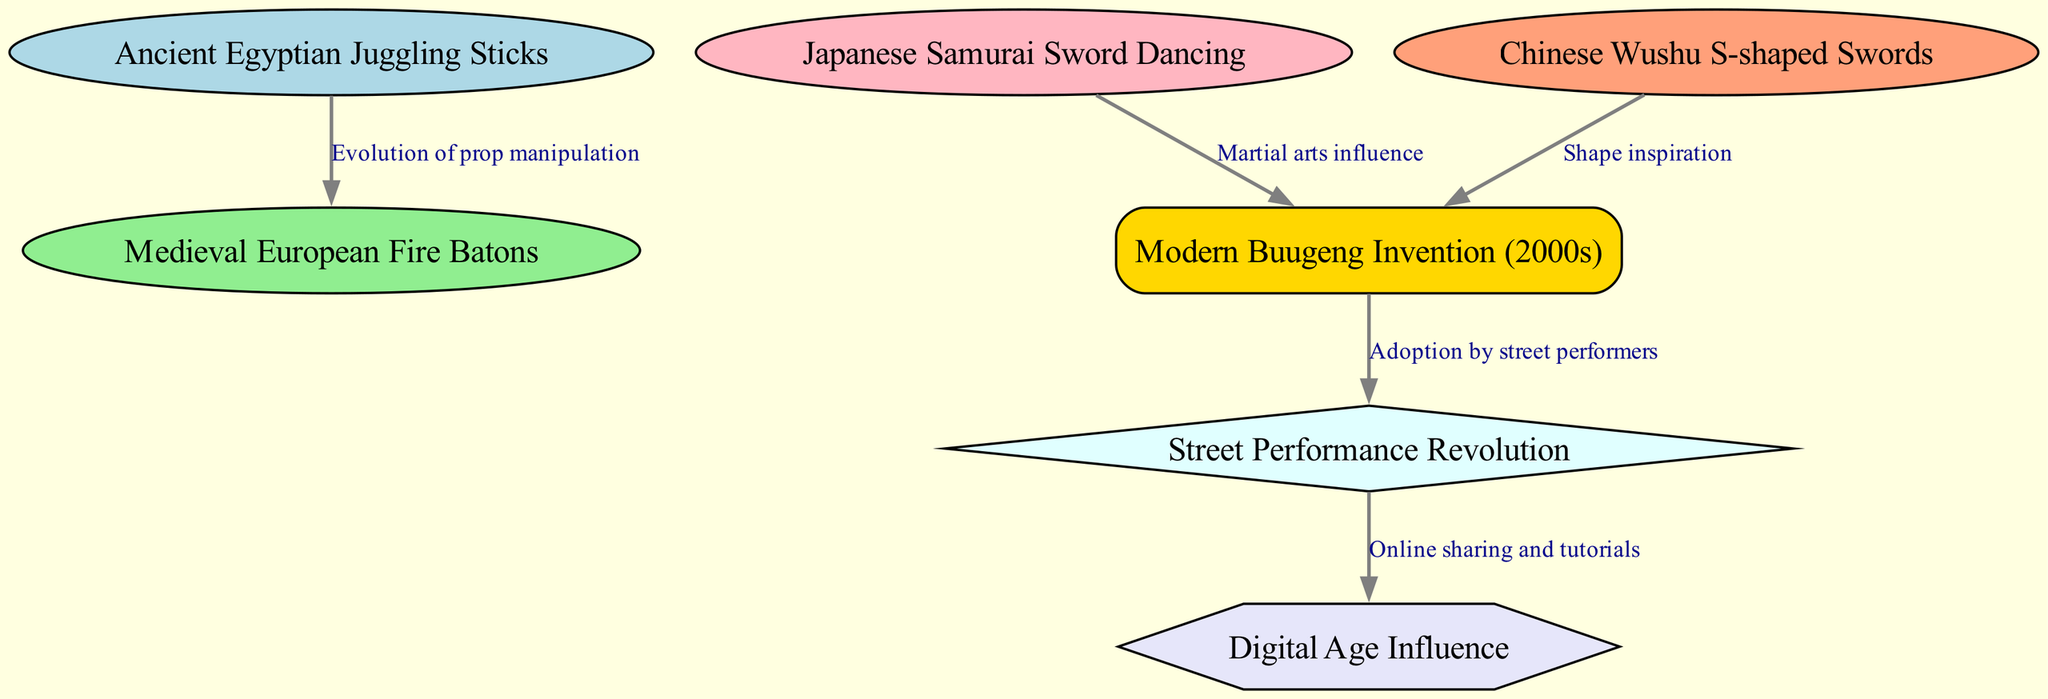What is the first node in the diagram? The diagram starts with "Ancient Egyptian Juggling Sticks," which is the first node listed.
Answer: Ancient Egyptian Juggling Sticks How many nodes are in the diagram? There are seven distinct nodes listed in the diagram, representing different cultural and historical elements.
Answer: 7 What relationship is shown between "Chinese Wushu S-shaped Swords" and "Modern Buugeng Invention (2000s)"? The relationship is labeled as "Shape inspiration," meaning the modern buugeng was inspired by the shape of the Chinese S-shaped swords.
Answer: Shape inspiration Which node follows "Street Performance Revolution" in the diagram? The node that follows "Street Performance Revolution" is "Digital Age Influence," indicating the progression from one to the other.
Answer: Digital Age Influence What is the relationship between "Ancient Egyptian Juggling Sticks" and "Medieval European Fire Batons"? The relationship is defined as the "Evolution of prop manipulation," indicating how one influenced the development of the other.
Answer: Evolution of prop manipulation How many edges connect to the "Modern Buugeng Invention (2000s)" node? The "Modern Buugeng Invention (2000s)" node connects to three edges indicating its relationships to other nodes.
Answer: 3 Which node directly influences street performers? The "Modern Buugeng Invention (2000s)" node directly influences street performers, as indicated by the edge leading to "Street Performance Revolution".
Answer: Modern Buugeng Invention (2000s) What type of node is "Street Performance Revolution"? "Street Performance Revolution" is a diamond-shaped node, indicating its unique status among the other nodes in the diagram.
Answer: Diamond What is the last node in the sequence of the diagram? The last node listed in the progression is "Digital Age Influence," signaling the final evolution in the context of S-staff props and performance art.
Answer: Digital Age Influence 